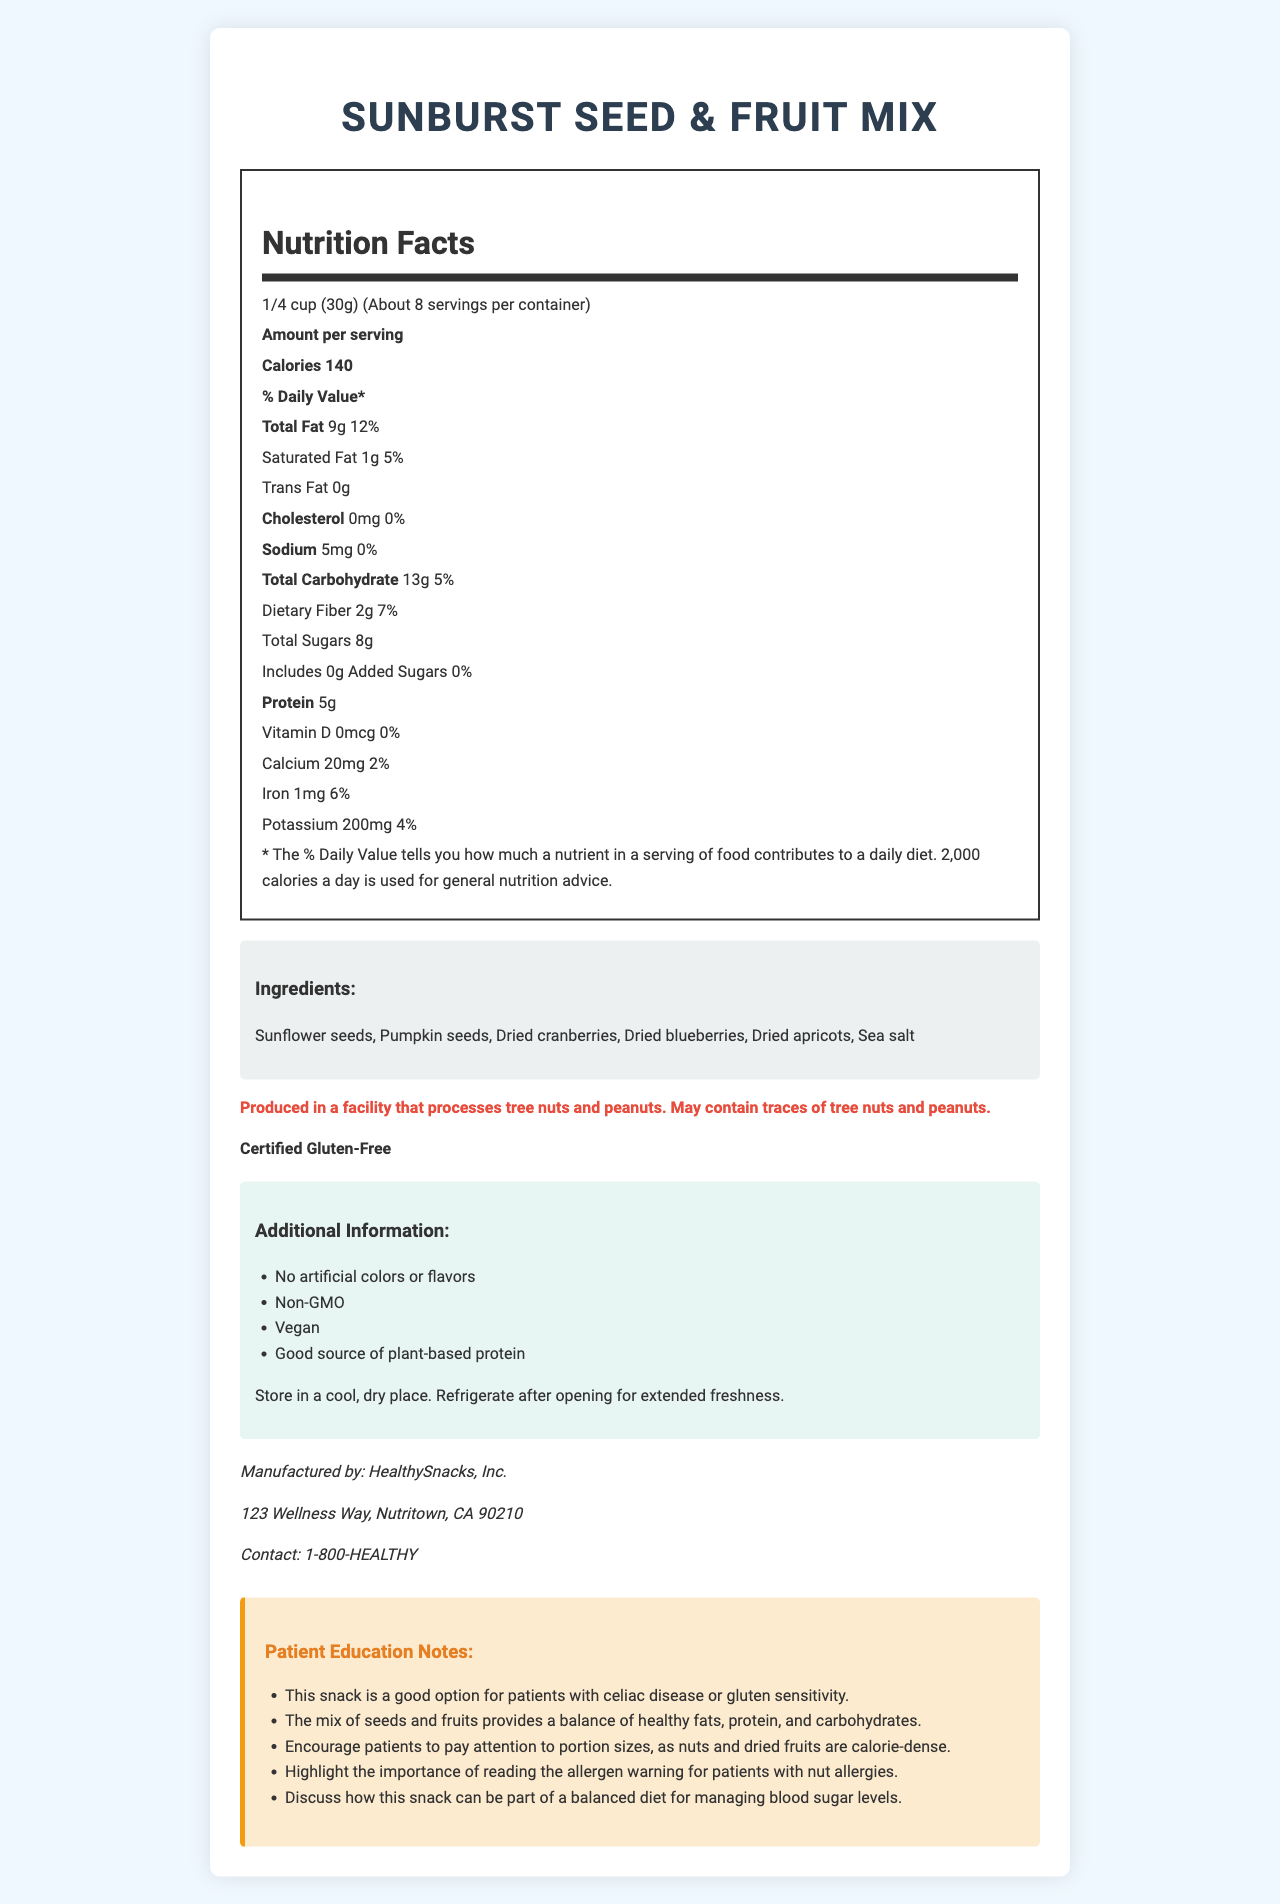What is the serving size of SunBurst Seed & Fruit Mix? The serving size is indicated at the top of the nutrition label as "1/4 cup (30g)".
Answer: 1/4 cup (30g) How many calories are there per serving? The document states "Calories 140" in the nutrition facts section.
Answer: 140 Which allergen warnings are provided for this snack? The allergen warning is clearly mentioned under the allergen section.
Answer: Produced in a facility that processes tree nuts and peanuts. May contain traces of tree nuts and peanuts. What is the manufacturer's contact phone number? The manufacturer's contact phone number is found in the manufacturer’s information section.
Answer: 1-800-HEALTHY What are the ingredients listed for this product? The ingredient list is provided under the ingredients section.
Answer: Sunflower seeds, Pumpkin seeds, Dried cranberries, Dried blueberries, Dried apricots, Sea salt What is the total fat content per serving? The total fat content is listed as "9g" in the nutrition facts section.
Answer: 9g How much dietary fiber is in one serving? The dietary fiber content is indicated as "2g" per serving in the nutrition facts section.
Answer: 2g Is this product gluten-free? The document includes a statement that says "Certified Gluten-Free".
Answer: Yes How many servings are there in one container? The document states "About 8" servings per container near the top of the nutrition facts section.
Answer: About 8 Is this snack a good option for patients with celiac disease or gluten sensitivity? According to the patient education notes, this snack is a good option for patients with celiac disease or gluten sensitivity.
Answer: Yes What is the daily value percentage of iron per serving? The daily value for iron is indicated as "6%" in the nutrition facts section.
Answer: 6% Where should you store this product after opening for extended freshness? A. In a warm place B. In a cool, dry place C. In the refrigerator D. In a sunny place The storage instructions specify to "Refrigerate after opening for extended freshness".
Answer: C. In the refrigerator Which of the following is not one of the additional claims made by the product? I. No artificial colors or flavors II. Non-GMO III. Organic IV. Vegan V. Good source of plant-based protein The document does not list "Organic" as an additional claim; it lists "No artificial colors or flavors," "Non-GMO," "Vegan," and "Good source of plant-based protein."
Answer: III. Organic Is there any trans fat in this product? The document clearly states "Trans Fat 0g" in the nutrition facts section.
Answer: No Summarize the main points of the document. The document comprehensively details the product's nutritional information, ingredients, allergen warnings, and additional health claims. It is targeted towards both general consumers and patients needing specific dietary considerations.
Answer: The document provides detailed information about the SunBurst Seed & Fruit Mix, including nutrition facts, ingredient list, allergen warnings, and additional claims. It emphasizes that the product is gluten-free, has no artificial colors or flavors, is non-GMO, and is vegan. Storage instructions and manufacturer contact information are also provided. Patient education notes highlight its suitability for people with celiac disease or gluten sensitivity and its nutritional benefits for a balanced diet. How much total carbohydrate does one serving contain? The total carbohydrate content per serving is listed as "13g" in the nutrition facts section.
Answer: 13g Why might this snack not be appropriate for someone with a tree nut allergy? The allergen warning states that the product may contain traces of tree nuts and peanuts, making it potentially unsafe for someone with a tree nut allergy.
Answer: May contain traces of tree nuts and peanuts Can you tell how long the product will remain fresh after opening? The document advises refrigerating the product after opening for extended freshness but does not provide a specific timeframe for how long it will remain fresh.
Answer: No, the exact duration is not specified. Is there any cholesterol in this snack? The document indicates "Cholesterol 0mg" per serving, meaning there is no cholesterol.
Answer: No What type of protein source is highlighted as an additional claim? A. Animal-based protein B. Whey protein C. Plant-based protein D. Soy protein The document highlights "Good source of plant-based protein" as an additional claim.
Answer: C. Plant-based protein 